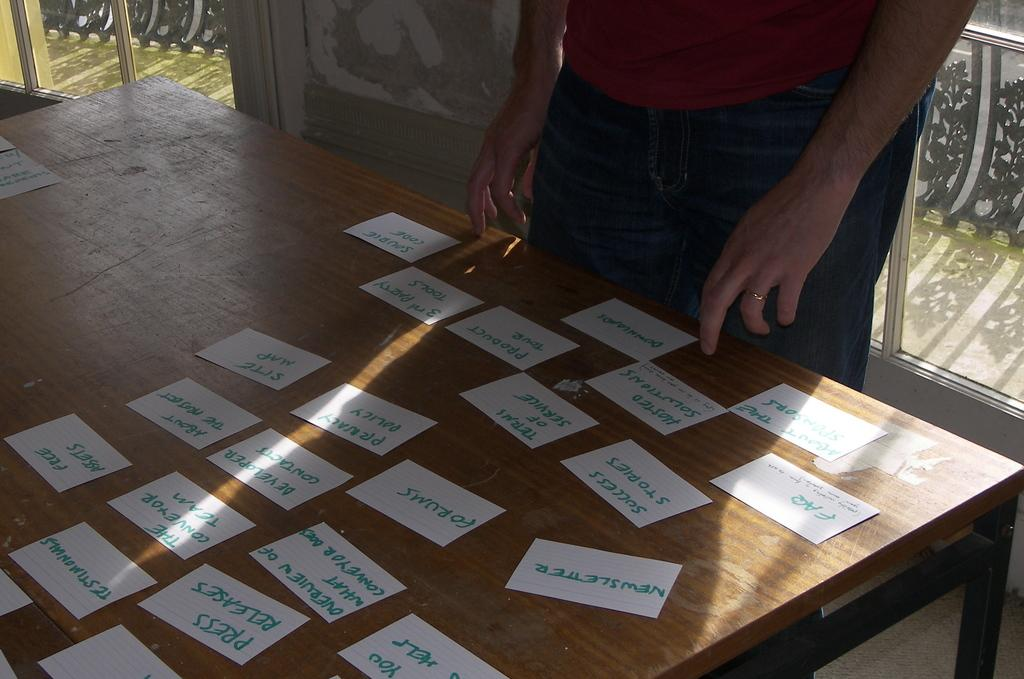What is the person in the image doing? The person is standing in front of a table. What is located above the table can be seen in the image? There are named papers above the table. What can be seen in the background of the image? There is a window and a wall visible in the background. How many feet does the person's aunt have in the image? There is no mention of an aunt or feet in the image, so this information cannot be determined. 